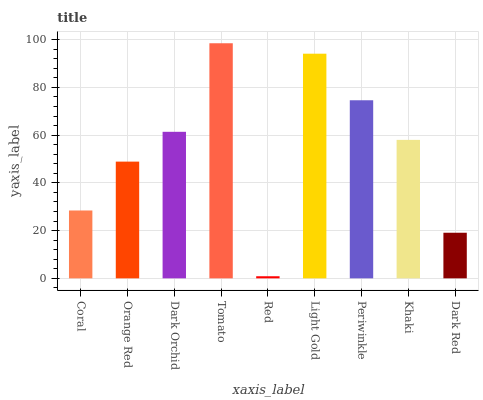Is Orange Red the minimum?
Answer yes or no. No. Is Orange Red the maximum?
Answer yes or no. No. Is Orange Red greater than Coral?
Answer yes or no. Yes. Is Coral less than Orange Red?
Answer yes or no. Yes. Is Coral greater than Orange Red?
Answer yes or no. No. Is Orange Red less than Coral?
Answer yes or no. No. Is Khaki the high median?
Answer yes or no. Yes. Is Khaki the low median?
Answer yes or no. Yes. Is Red the high median?
Answer yes or no. No. Is Red the low median?
Answer yes or no. No. 